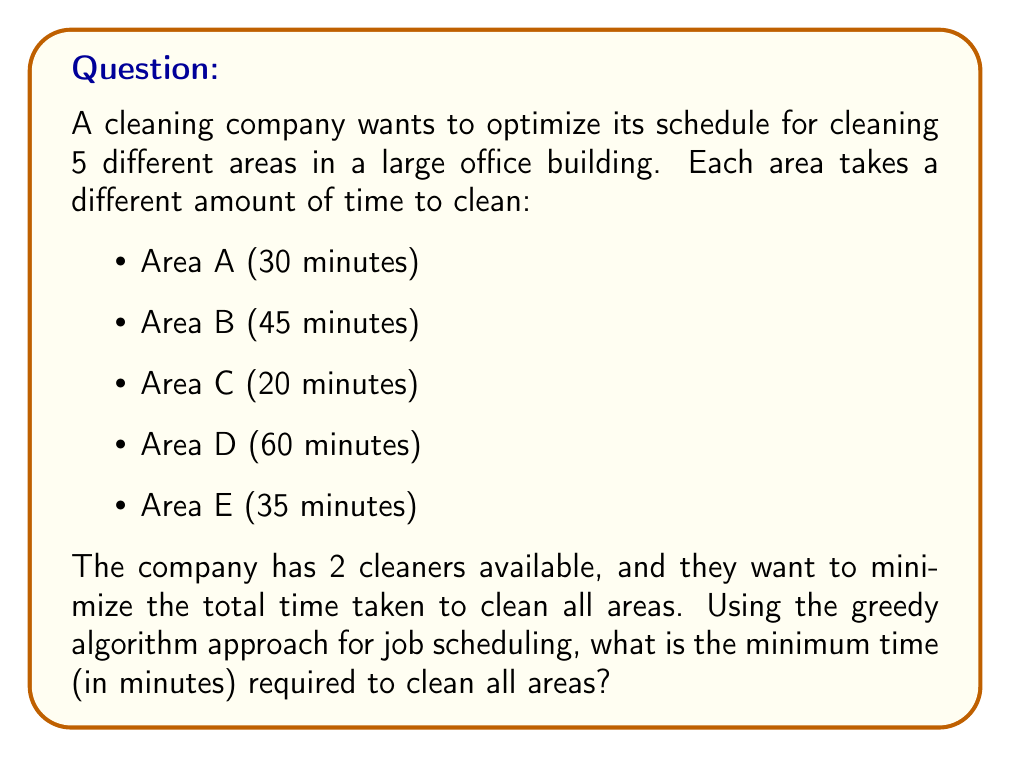Provide a solution to this math problem. To solve this problem using the greedy algorithm for job scheduling, we'll follow these steps:

1. Sort the cleaning times in descending order:
   D (60), B (45), E (35), A (30), C (20)

2. Assign jobs to cleaners, always choosing the available cleaner with the least current workload:

   Cleaner 1: D (60)
   Cleaner 2: B (45)

   Cleaner 1: E (35) [Current total: 95]
   Cleaner 2: A (30) [Current total: 75]

   Cleaner 2: C (20) [Current total: 95]

3. The minimum time required is the maximum of the two cleaners' total times:

   $$\text{Minimum time} = \max(95, 95) = 95\text{ minutes}$$

This greedy approach works well for job scheduling problems as it always assigns the next largest job to the cleaner with the least current workload, which tends to balance the work and minimize the overall time.

It's worth noting that while this greedy algorithm often produces optimal or near-optimal solutions for job scheduling, it doesn't guarantee the absolute optimal solution for all cases. However, it's efficient and generally provides good results for practical applications like cleaning schedules.
Answer: 95 minutes 